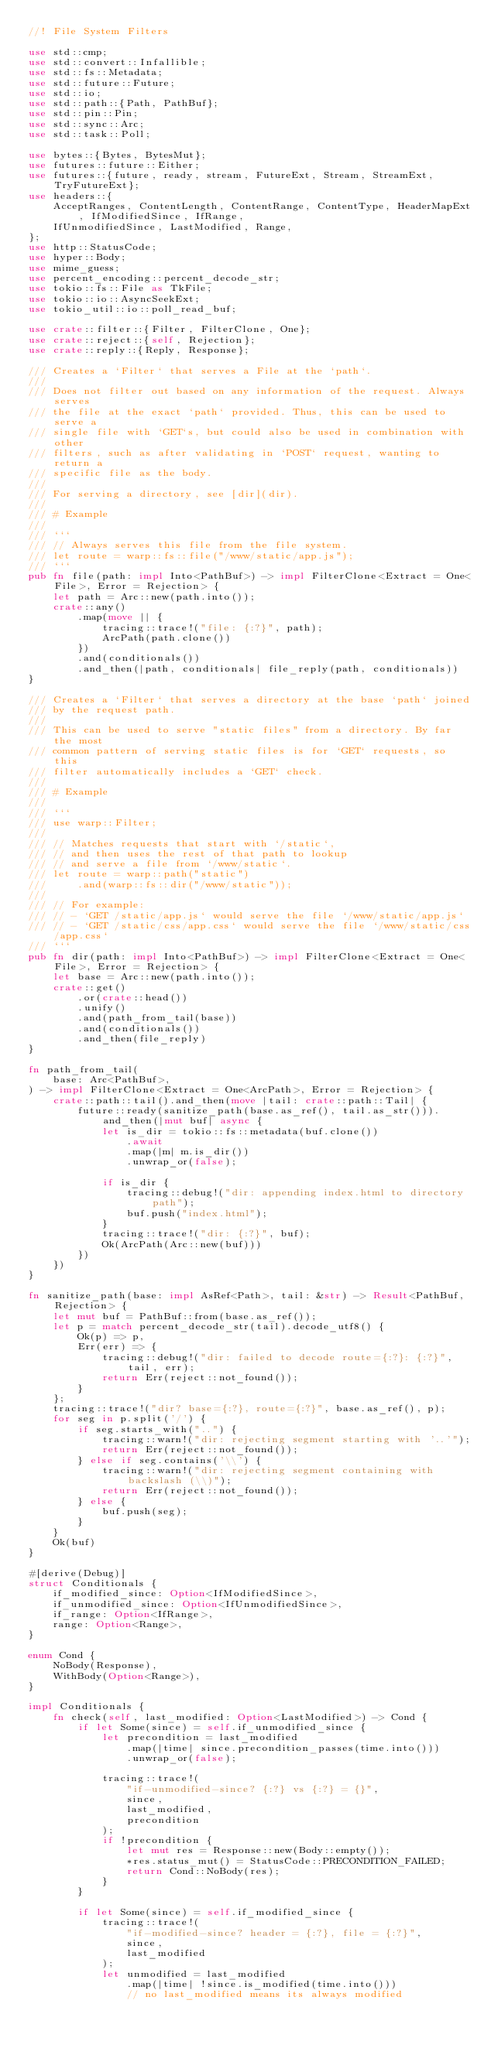<code> <loc_0><loc_0><loc_500><loc_500><_Rust_>//! File System Filters

use std::cmp;
use std::convert::Infallible;
use std::fs::Metadata;
use std::future::Future;
use std::io;
use std::path::{Path, PathBuf};
use std::pin::Pin;
use std::sync::Arc;
use std::task::Poll;

use bytes::{Bytes, BytesMut};
use futures::future::Either;
use futures::{future, ready, stream, FutureExt, Stream, StreamExt, TryFutureExt};
use headers::{
    AcceptRanges, ContentLength, ContentRange, ContentType, HeaderMapExt, IfModifiedSince, IfRange,
    IfUnmodifiedSince, LastModified, Range,
};
use http::StatusCode;
use hyper::Body;
use mime_guess;
use percent_encoding::percent_decode_str;
use tokio::fs::File as TkFile;
use tokio::io::AsyncSeekExt;
use tokio_util::io::poll_read_buf;

use crate::filter::{Filter, FilterClone, One};
use crate::reject::{self, Rejection};
use crate::reply::{Reply, Response};

/// Creates a `Filter` that serves a File at the `path`.
///
/// Does not filter out based on any information of the request. Always serves
/// the file at the exact `path` provided. Thus, this can be used to serve a
/// single file with `GET`s, but could also be used in combination with other
/// filters, such as after validating in `POST` request, wanting to return a
/// specific file as the body.
///
/// For serving a directory, see [dir](dir).
///
/// # Example
///
/// ```
/// // Always serves this file from the file system.
/// let route = warp::fs::file("/www/static/app.js");
/// ```
pub fn file(path: impl Into<PathBuf>) -> impl FilterClone<Extract = One<File>, Error = Rejection> {
    let path = Arc::new(path.into());
    crate::any()
        .map(move || {
            tracing::trace!("file: {:?}", path);
            ArcPath(path.clone())
        })
        .and(conditionals())
        .and_then(|path, conditionals| file_reply(path, conditionals))
}

/// Creates a `Filter` that serves a directory at the base `path` joined
/// by the request path.
///
/// This can be used to serve "static files" from a directory. By far the most
/// common pattern of serving static files is for `GET` requests, so this
/// filter automatically includes a `GET` check.
///
/// # Example
///
/// ```
/// use warp::Filter;
///
/// // Matches requests that start with `/static`,
/// // and then uses the rest of that path to lookup
/// // and serve a file from `/www/static`.
/// let route = warp::path("static")
///     .and(warp::fs::dir("/www/static"));
///
/// // For example:
/// // - `GET /static/app.js` would serve the file `/www/static/app.js`
/// // - `GET /static/css/app.css` would serve the file `/www/static/css/app.css`
/// ```
pub fn dir(path: impl Into<PathBuf>) -> impl FilterClone<Extract = One<File>, Error = Rejection> {
    let base = Arc::new(path.into());
    crate::get()
        .or(crate::head())
        .unify()
        .and(path_from_tail(base))
        .and(conditionals())
        .and_then(file_reply)
}

fn path_from_tail(
    base: Arc<PathBuf>,
) -> impl FilterClone<Extract = One<ArcPath>, Error = Rejection> {
    crate::path::tail().and_then(move |tail: crate::path::Tail| {
        future::ready(sanitize_path(base.as_ref(), tail.as_str())).and_then(|mut buf| async {
            let is_dir = tokio::fs::metadata(buf.clone())
                .await
                .map(|m| m.is_dir())
                .unwrap_or(false);

            if is_dir {
                tracing::debug!("dir: appending index.html to directory path");
                buf.push("index.html");
            }
            tracing::trace!("dir: {:?}", buf);
            Ok(ArcPath(Arc::new(buf)))
        })
    })
}

fn sanitize_path(base: impl AsRef<Path>, tail: &str) -> Result<PathBuf, Rejection> {
    let mut buf = PathBuf::from(base.as_ref());
    let p = match percent_decode_str(tail).decode_utf8() {
        Ok(p) => p,
        Err(err) => {
            tracing::debug!("dir: failed to decode route={:?}: {:?}", tail, err);
            return Err(reject::not_found());
        }
    };
    tracing::trace!("dir? base={:?}, route={:?}", base.as_ref(), p);
    for seg in p.split('/') {
        if seg.starts_with("..") {
            tracing::warn!("dir: rejecting segment starting with '..'");
            return Err(reject::not_found());
        } else if seg.contains('\\') {
            tracing::warn!("dir: rejecting segment containing with backslash (\\)");
            return Err(reject::not_found());
        } else {
            buf.push(seg);
        }
    }
    Ok(buf)
}

#[derive(Debug)]
struct Conditionals {
    if_modified_since: Option<IfModifiedSince>,
    if_unmodified_since: Option<IfUnmodifiedSince>,
    if_range: Option<IfRange>,
    range: Option<Range>,
}

enum Cond {
    NoBody(Response),
    WithBody(Option<Range>),
}

impl Conditionals {
    fn check(self, last_modified: Option<LastModified>) -> Cond {
        if let Some(since) = self.if_unmodified_since {
            let precondition = last_modified
                .map(|time| since.precondition_passes(time.into()))
                .unwrap_or(false);

            tracing::trace!(
                "if-unmodified-since? {:?} vs {:?} = {}",
                since,
                last_modified,
                precondition
            );
            if !precondition {
                let mut res = Response::new(Body::empty());
                *res.status_mut() = StatusCode::PRECONDITION_FAILED;
                return Cond::NoBody(res);
            }
        }

        if let Some(since) = self.if_modified_since {
            tracing::trace!(
                "if-modified-since? header = {:?}, file = {:?}",
                since,
                last_modified
            );
            let unmodified = last_modified
                .map(|time| !since.is_modified(time.into()))
                // no last_modified means its always modified</code> 